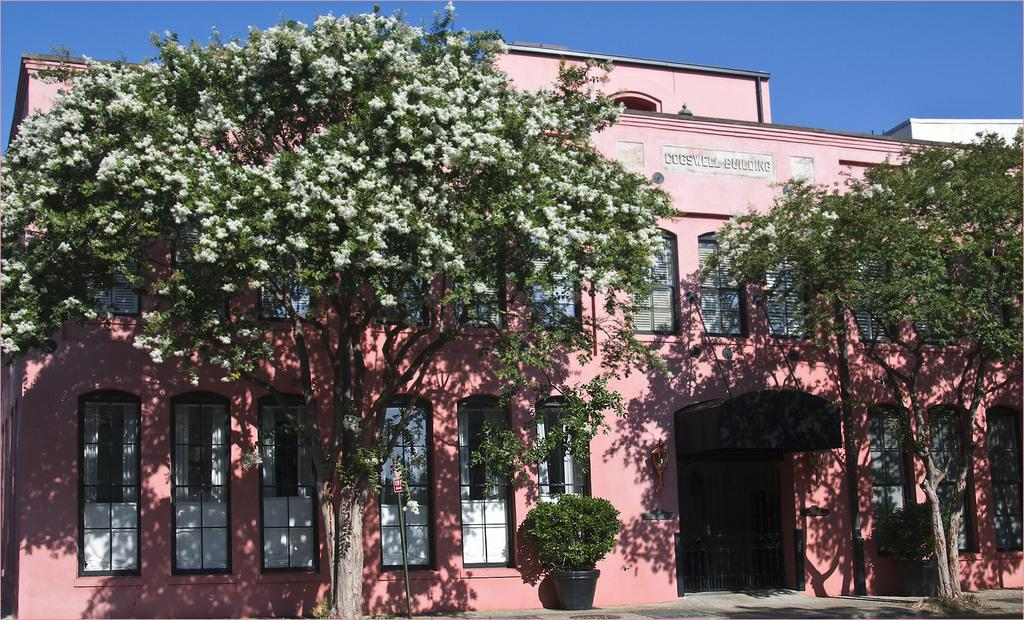What type of vegetation is in front of the building in the image? There are two trees in front of the building in the image. What is the color of the building? The building is pink in color. Can you describe the plant in the image? There is a plant in a plant pot in the image. What can be seen in the background of the image? The sky is visible in the background of the image. Is there a beggar performing magic tricks in front of the building? There is no beggar or magic tricks present in the image. What sense is being used to perceive the plant in the image? The question about the sense being used to perceive the plant is not relevant to the image, as it does not contain any information about the sense being used. 